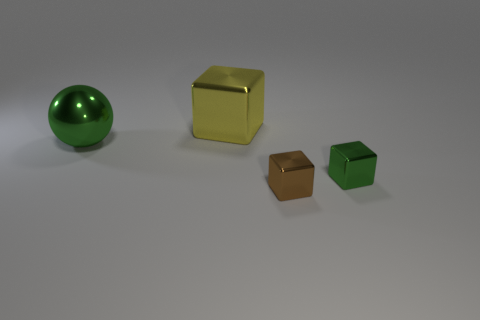What could be the possible uses of these objects in real-world settings? These objects could serve a variety of purposes. The large sphere could be part of a decorative piece or a child's toy, while the cubes might be used in educational settings to teach geometry or spatial reasoning. They could also be artistic props or elements in a visual display to showcase reflection and color properties of materials. 